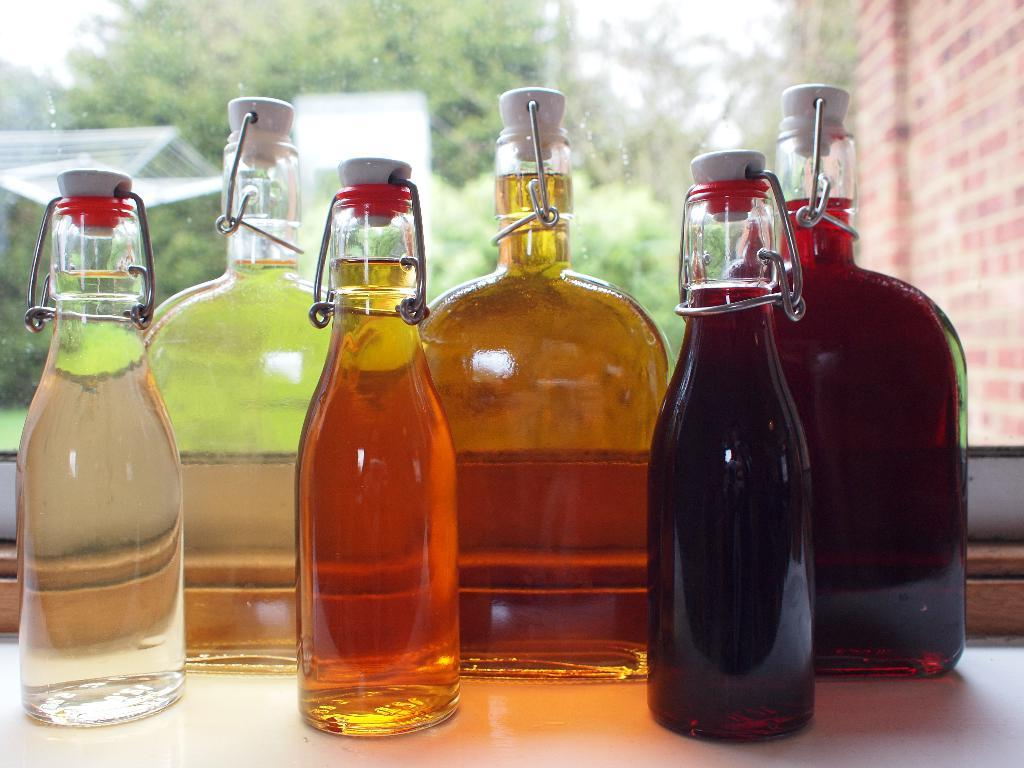How many bottles are visible in the image? There are six bottles in the image. What is inside the bottles? The bottles contain a drink. What can be seen in the background of the image? There are trees in the background of the image. What is located on the right side of the image? There is a wall on the right side of the image. What type of cloud can be seen bursting in the image? There is no cloud or bursting event present in the image. 